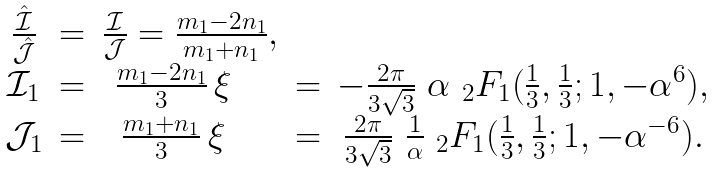<formula> <loc_0><loc_0><loc_500><loc_500>\begin{matrix} \frac { \hat { \mathcal { I } } } { \hat { \mathcal { J } } } & = & \frac { \mathcal { I } } { \mathcal { J } } = \frac { m _ { 1 } - 2 n _ { 1 } } { m _ { 1 } + n _ { 1 } } , \\ \mathcal { I } _ { 1 } & = & \frac { m _ { 1 } - 2 n _ { 1 } } { 3 } \, \xi \quad & = & - \frac { 2 \pi } { 3 \sqrt { 3 } } \ \alpha \ { _ { 2 } F _ { 1 } } ( \frac { 1 } { 3 } , \frac { 1 } { 3 } ; 1 , - \alpha ^ { 6 } ) , \\ \mathcal { J } _ { 1 } & = & \frac { m _ { 1 } + n _ { 1 } } { 3 } \, \xi \quad & = & \frac { 2 \pi } { 3 \sqrt { 3 } } \ \frac { 1 } { \alpha } \ { _ { 2 } F _ { 1 } } ( \frac { 1 } { 3 } , \frac { 1 } { 3 } ; 1 , - \alpha ^ { - 6 } ) . \end{matrix}</formula> 